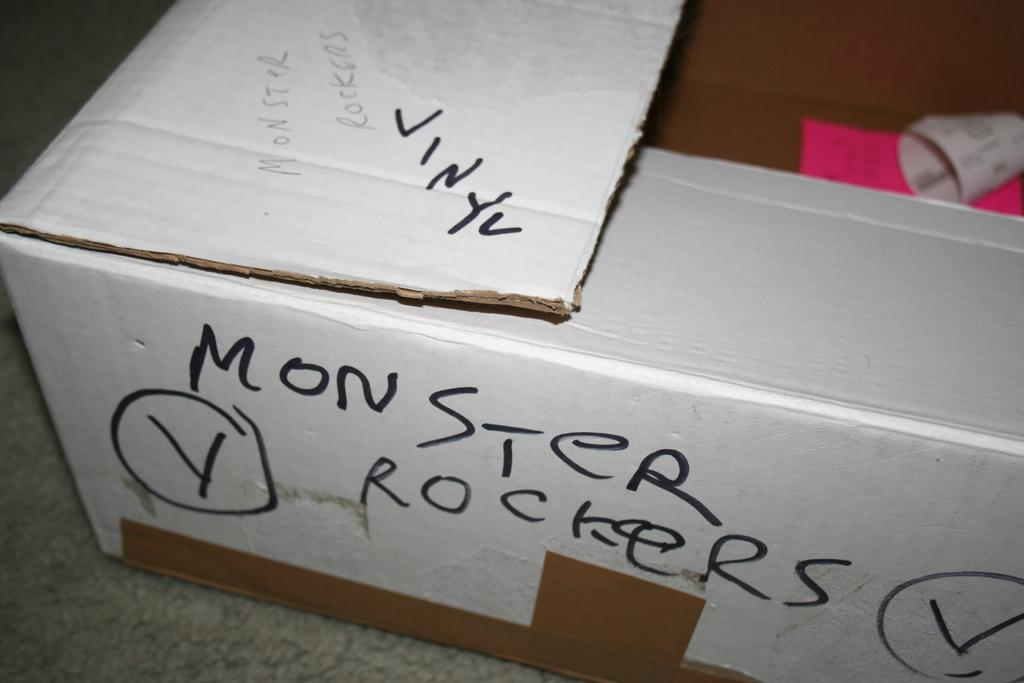<image>
Provide a brief description of the given image. a white box on the ground that has 'monster rockers' written on it in black 